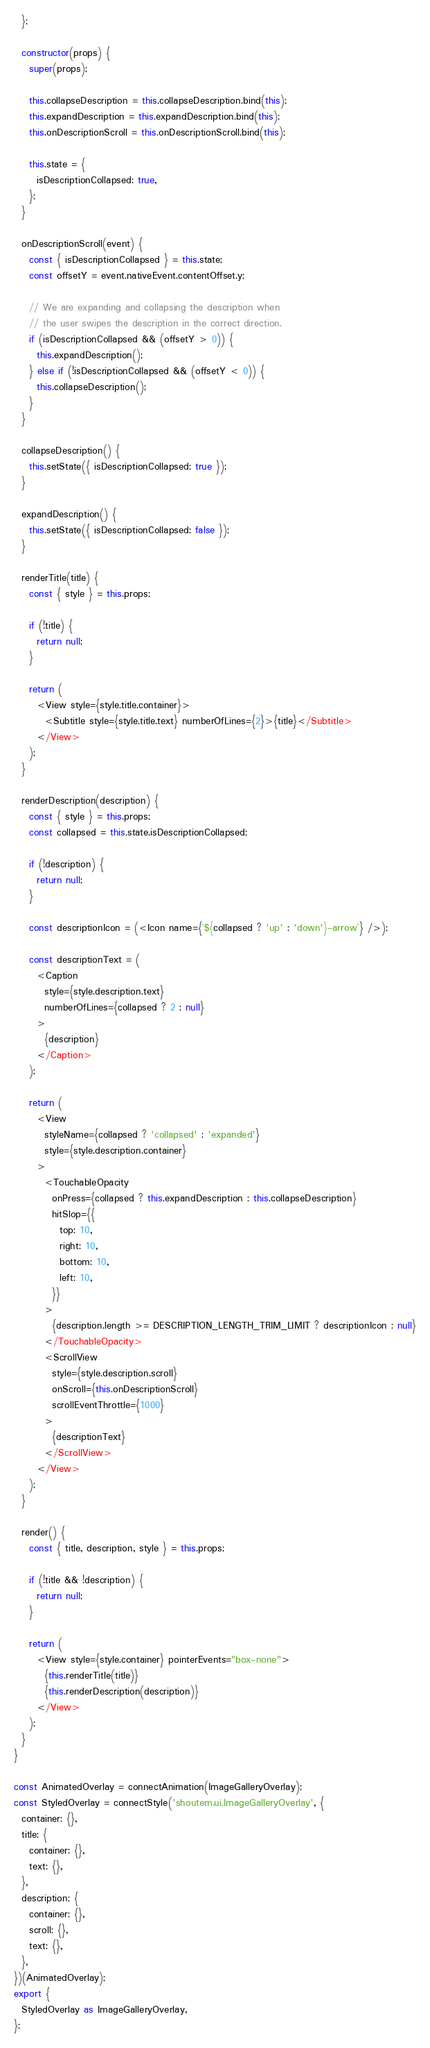Convert code to text. <code><loc_0><loc_0><loc_500><loc_500><_JavaScript_>  };

  constructor(props) {
    super(props);

    this.collapseDescription = this.collapseDescription.bind(this);
    this.expandDescription = this.expandDescription.bind(this);
    this.onDescriptionScroll = this.onDescriptionScroll.bind(this);

    this.state = {
      isDescriptionCollapsed: true,
    };
  }

  onDescriptionScroll(event) {
    const { isDescriptionCollapsed } = this.state;
    const offsetY = event.nativeEvent.contentOffset.y;

    // We are expanding and collapsing the description when
    // the user swipes the description in the correct direction.
    if (isDescriptionCollapsed && (offsetY > 0)) {
      this.expandDescription();
    } else if (!isDescriptionCollapsed && (offsetY < 0)) {
      this.collapseDescription();
    }
  }

  collapseDescription() {
    this.setState({ isDescriptionCollapsed: true });
  }

  expandDescription() {
    this.setState({ isDescriptionCollapsed: false });
  }

  renderTitle(title) {
    const { style } = this.props;

    if (!title) {
      return null;
    }

    return (
      <View style={style.title.container}>
        <Subtitle style={style.title.text} numberOfLines={2}>{title}</Subtitle>
      </View>
    );
  }

  renderDescription(description) {
    const { style } = this.props;
    const collapsed = this.state.isDescriptionCollapsed;

    if (!description) {
      return null;
    }

    const descriptionIcon = (<Icon name={`${collapsed ? 'up' : 'down'}-arrow`} />);

    const descriptionText = (
      <Caption
        style={style.description.text}
        numberOfLines={collapsed ? 2 : null}
      >
        {description}
      </Caption>
    );

    return (
      <View
        styleName={collapsed ? 'collapsed' : 'expanded'}
        style={style.description.container}
      >
        <TouchableOpacity
          onPress={collapsed ? this.expandDescription : this.collapseDescription}
          hitSlop={{
            top: 10,
            right: 10,
            bottom: 10,
            left: 10,
          }}
        >
          {description.length >= DESCRIPTION_LENGTH_TRIM_LIMIT ? descriptionIcon : null}
        </TouchableOpacity>
        <ScrollView
          style={style.description.scroll}
          onScroll={this.onDescriptionScroll}
          scrollEventThrottle={1000}
        >
          {descriptionText}
        </ScrollView>
      </View>
    );
  }

  render() {
    const { title, description, style } = this.props;

    if (!title && !description) {
      return null;
    }

    return (
      <View style={style.container} pointerEvents="box-none">
        {this.renderTitle(title)}
        {this.renderDescription(description)}
      </View>
    );
  }
}

const AnimatedOverlay = connectAnimation(ImageGalleryOverlay);
const StyledOverlay = connectStyle('shoutem.ui.ImageGalleryOverlay', {
  container: {},
  title: {
    container: {},
    text: {},
  },
  description: {
    container: {},
    scroll: {},
    text: {},
  },
})(AnimatedOverlay);
export {
  StyledOverlay as ImageGalleryOverlay,
};
</code> 